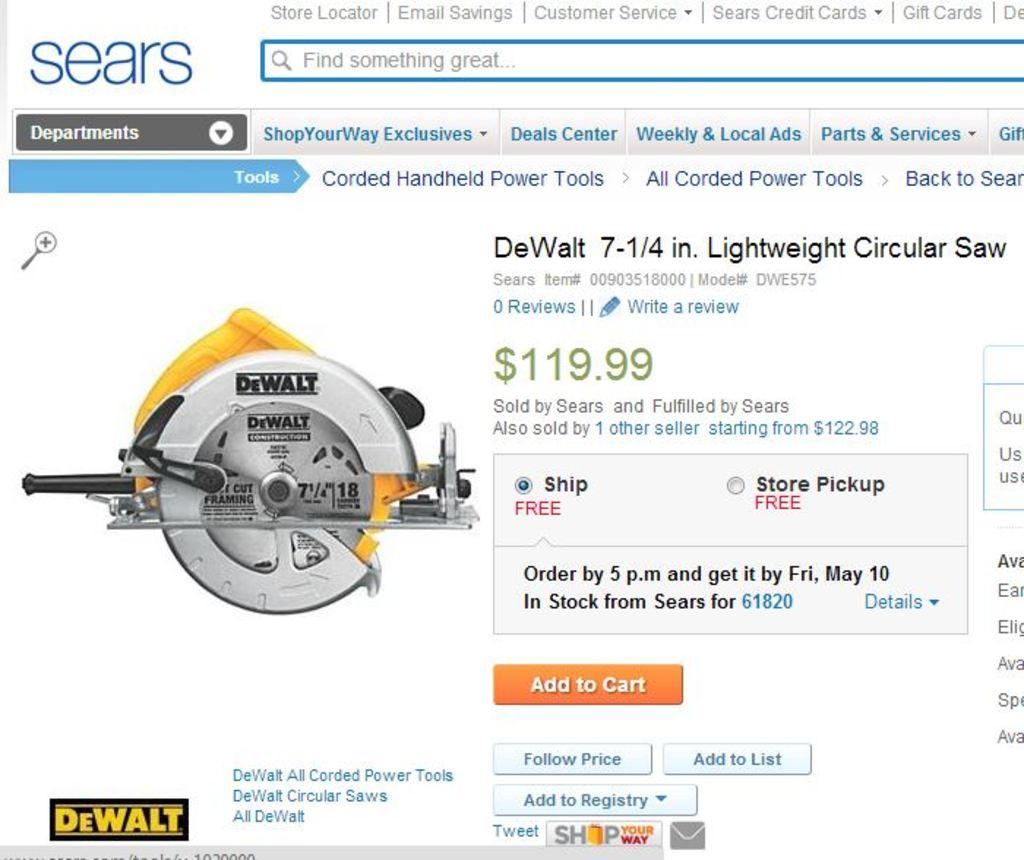What is the main subject of the image? The main subject of the image is a web page. What can be found on the web page? There is text on the web page. What else is depicted on the web page? There is a machine depicted on the web page. What type of wood is used in the door depicted on the web page? There is no door depicted on the web page. 